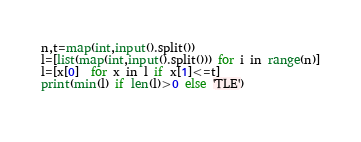<code> <loc_0><loc_0><loc_500><loc_500><_Python_>n,t=map(int,input().split())
l=[list(map(int,input().split())) for i in range(n)]
l=[x[0]  for x in l if x[1]<=t]
print(min(l) if len(l)>0 else 'TLE')
	</code> 